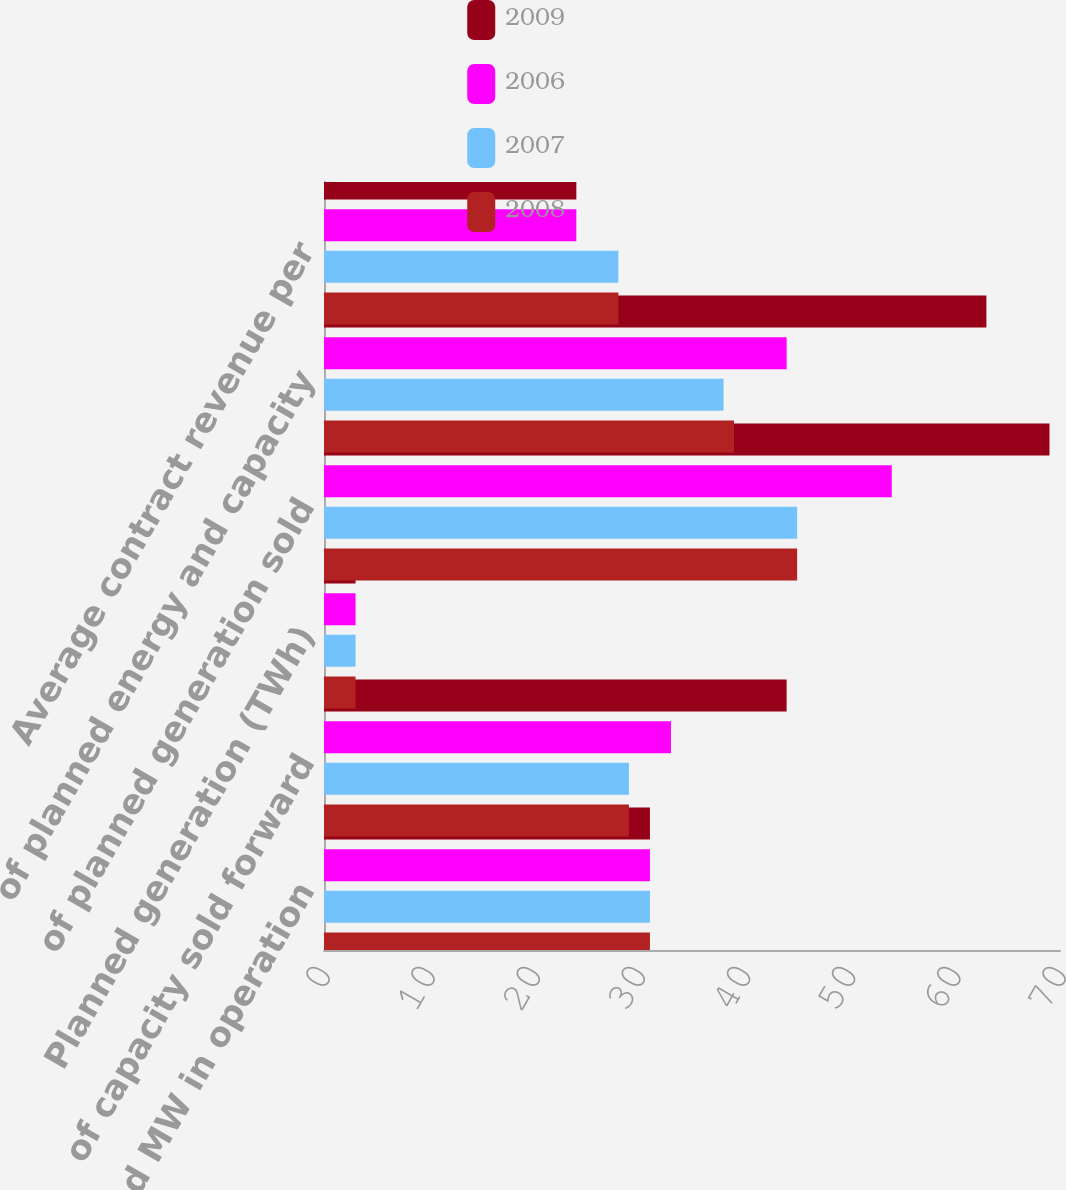Convert chart to OTSL. <chart><loc_0><loc_0><loc_500><loc_500><stacked_bar_chart><ecel><fcel>Planned MW in operation<fcel>of capacity sold forward<fcel>Planned generation (TWh)<fcel>of planned generation sold<fcel>of planned energy and capacity<fcel>Average contract revenue per<nl><fcel>2009<fcel>31<fcel>44<fcel>3<fcel>69<fcel>63<fcel>24<nl><fcel>2006<fcel>31<fcel>33<fcel>3<fcel>54<fcel>44<fcel>24<nl><fcel>2007<fcel>31<fcel>29<fcel>3<fcel>45<fcel>38<fcel>28<nl><fcel>2008<fcel>31<fcel>29<fcel>3<fcel>45<fcel>39<fcel>28<nl></chart> 